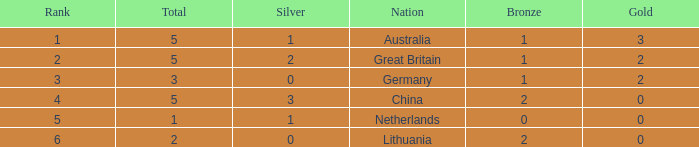What is the total number when silver is 0, bronze is 1, and the standing is less than 3? 0.0. 